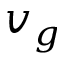Convert formula to latex. <formula><loc_0><loc_0><loc_500><loc_500>v _ { g }</formula> 